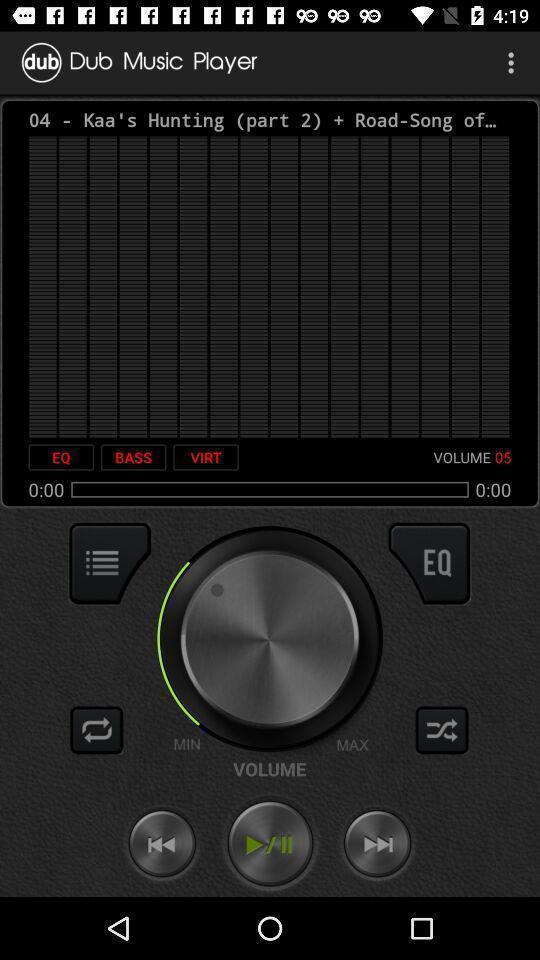Tell me about the visual elements in this screen capture. Page showing options from a music app. Give me a summary of this screen capture. Page showing different control in music player. 